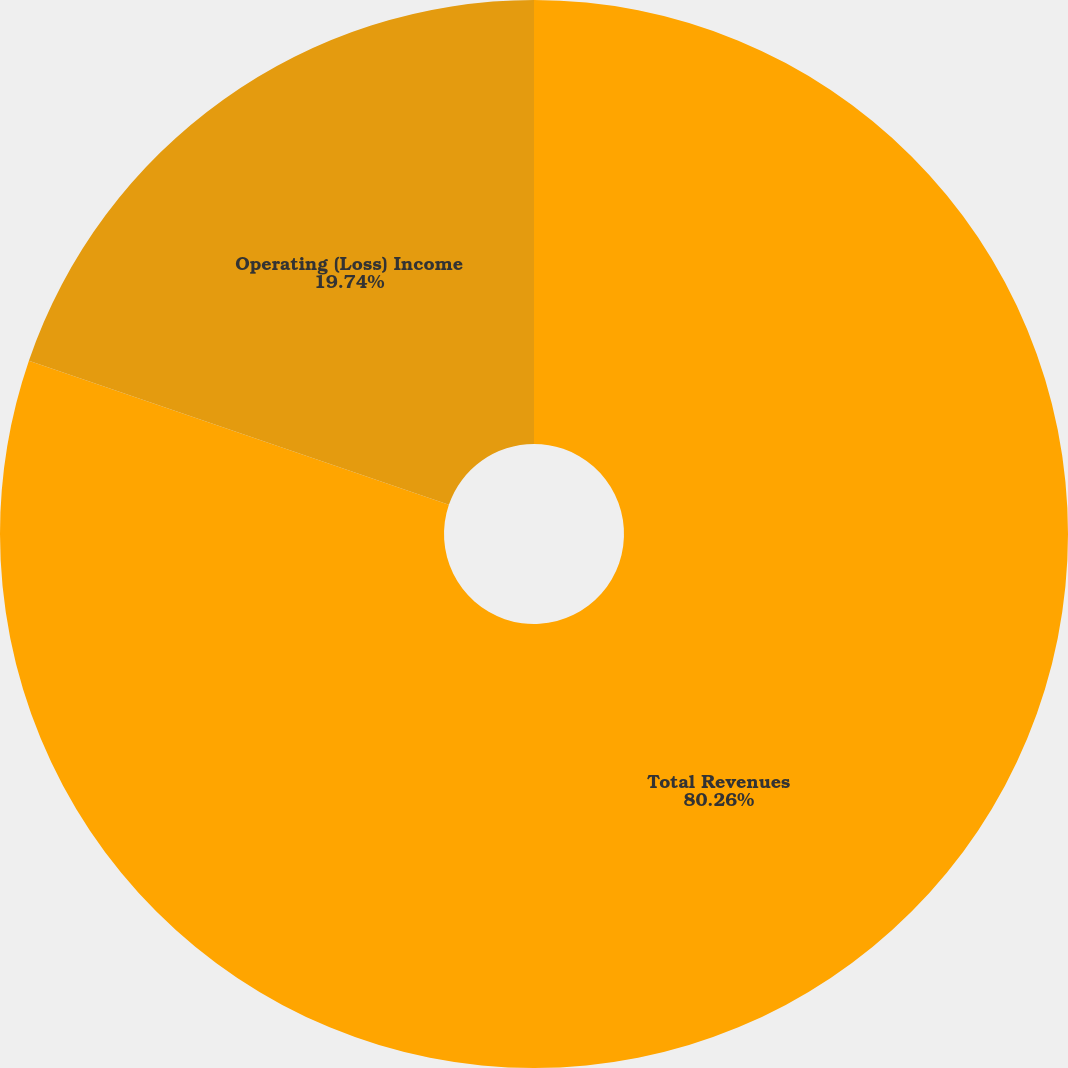Convert chart to OTSL. <chart><loc_0><loc_0><loc_500><loc_500><pie_chart><fcel>Total Revenues<fcel>Operating (Loss) Income<nl><fcel>80.26%<fcel>19.74%<nl></chart> 